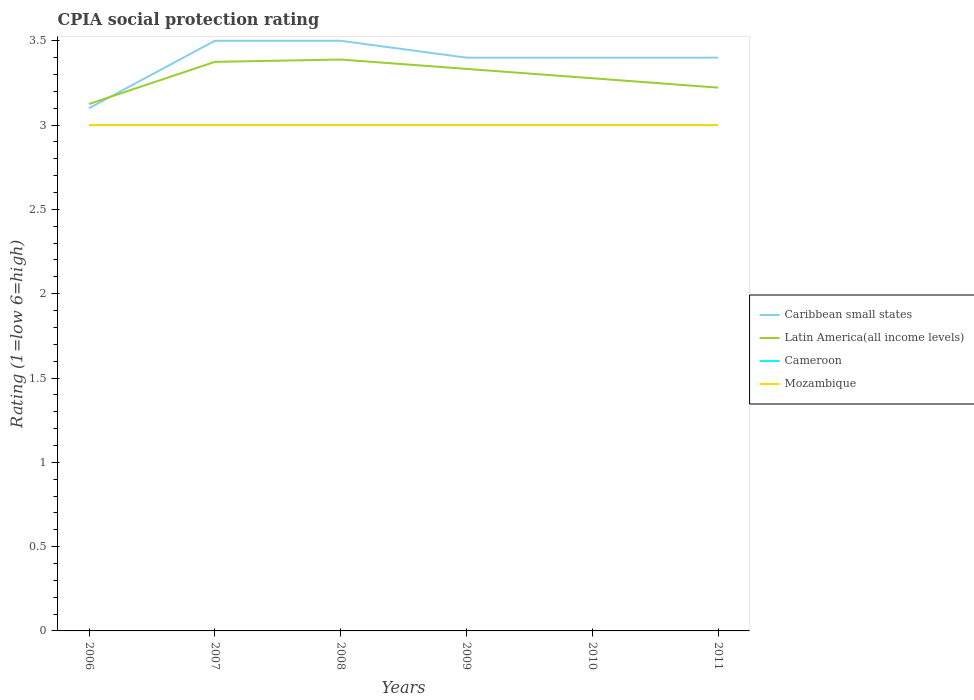How many different coloured lines are there?
Ensure brevity in your answer.  4. Does the line corresponding to Cameroon intersect with the line corresponding to Latin America(all income levels)?
Ensure brevity in your answer.  No. Across all years, what is the maximum CPIA rating in Latin America(all income levels)?
Provide a short and direct response. 3.12. In which year was the CPIA rating in Latin America(all income levels) maximum?
Give a very brief answer. 2006. What is the total CPIA rating in Latin America(all income levels) in the graph?
Your answer should be very brief. 0.06. What is the difference between the highest and the second highest CPIA rating in Latin America(all income levels)?
Provide a short and direct response. 0.26. Is the CPIA rating in Cameroon strictly greater than the CPIA rating in Caribbean small states over the years?
Keep it short and to the point. Yes. How many lines are there?
Provide a short and direct response. 4. What is the difference between two consecutive major ticks on the Y-axis?
Your answer should be compact. 0.5. Are the values on the major ticks of Y-axis written in scientific E-notation?
Make the answer very short. No. Does the graph contain grids?
Offer a terse response. No. How many legend labels are there?
Ensure brevity in your answer.  4. How are the legend labels stacked?
Make the answer very short. Vertical. What is the title of the graph?
Give a very brief answer. CPIA social protection rating. Does "American Samoa" appear as one of the legend labels in the graph?
Your answer should be compact. No. What is the label or title of the Y-axis?
Your response must be concise. Rating (1=low 6=high). What is the Rating (1=low 6=high) in Latin America(all income levels) in 2006?
Ensure brevity in your answer.  3.12. What is the Rating (1=low 6=high) of Latin America(all income levels) in 2007?
Give a very brief answer. 3.38. What is the Rating (1=low 6=high) of Latin America(all income levels) in 2008?
Keep it short and to the point. 3.39. What is the Rating (1=low 6=high) in Cameroon in 2008?
Your response must be concise. 3. What is the Rating (1=low 6=high) of Caribbean small states in 2009?
Provide a short and direct response. 3.4. What is the Rating (1=low 6=high) of Latin America(all income levels) in 2009?
Provide a succinct answer. 3.33. What is the Rating (1=low 6=high) of Cameroon in 2009?
Ensure brevity in your answer.  3. What is the Rating (1=low 6=high) of Caribbean small states in 2010?
Your answer should be compact. 3.4. What is the Rating (1=low 6=high) of Latin America(all income levels) in 2010?
Make the answer very short. 3.28. What is the Rating (1=low 6=high) in Cameroon in 2010?
Offer a very short reply. 3. What is the Rating (1=low 6=high) of Caribbean small states in 2011?
Provide a succinct answer. 3.4. What is the Rating (1=low 6=high) of Latin America(all income levels) in 2011?
Offer a very short reply. 3.22. What is the Rating (1=low 6=high) of Cameroon in 2011?
Ensure brevity in your answer.  3. What is the Rating (1=low 6=high) in Mozambique in 2011?
Offer a very short reply. 3. Across all years, what is the maximum Rating (1=low 6=high) of Caribbean small states?
Offer a very short reply. 3.5. Across all years, what is the maximum Rating (1=low 6=high) in Latin America(all income levels)?
Give a very brief answer. 3.39. Across all years, what is the maximum Rating (1=low 6=high) of Cameroon?
Provide a short and direct response. 3. Across all years, what is the maximum Rating (1=low 6=high) of Mozambique?
Your answer should be compact. 3. Across all years, what is the minimum Rating (1=low 6=high) in Caribbean small states?
Offer a very short reply. 3.1. Across all years, what is the minimum Rating (1=low 6=high) in Latin America(all income levels)?
Provide a succinct answer. 3.12. Across all years, what is the minimum Rating (1=low 6=high) of Cameroon?
Provide a succinct answer. 3. Across all years, what is the minimum Rating (1=low 6=high) in Mozambique?
Offer a very short reply. 3. What is the total Rating (1=low 6=high) of Caribbean small states in the graph?
Your answer should be very brief. 20.3. What is the total Rating (1=low 6=high) of Latin America(all income levels) in the graph?
Make the answer very short. 19.72. What is the difference between the Rating (1=low 6=high) of Caribbean small states in 2006 and that in 2007?
Offer a very short reply. -0.4. What is the difference between the Rating (1=low 6=high) in Latin America(all income levels) in 2006 and that in 2007?
Offer a terse response. -0.25. What is the difference between the Rating (1=low 6=high) in Cameroon in 2006 and that in 2007?
Offer a very short reply. 0. What is the difference between the Rating (1=low 6=high) of Caribbean small states in 2006 and that in 2008?
Offer a very short reply. -0.4. What is the difference between the Rating (1=low 6=high) in Latin America(all income levels) in 2006 and that in 2008?
Your answer should be compact. -0.26. What is the difference between the Rating (1=low 6=high) in Cameroon in 2006 and that in 2008?
Give a very brief answer. 0. What is the difference between the Rating (1=low 6=high) of Mozambique in 2006 and that in 2008?
Your answer should be very brief. 0. What is the difference between the Rating (1=low 6=high) of Latin America(all income levels) in 2006 and that in 2009?
Make the answer very short. -0.21. What is the difference between the Rating (1=low 6=high) in Cameroon in 2006 and that in 2009?
Your response must be concise. 0. What is the difference between the Rating (1=low 6=high) in Latin America(all income levels) in 2006 and that in 2010?
Ensure brevity in your answer.  -0.15. What is the difference between the Rating (1=low 6=high) in Mozambique in 2006 and that in 2010?
Ensure brevity in your answer.  0. What is the difference between the Rating (1=low 6=high) of Latin America(all income levels) in 2006 and that in 2011?
Make the answer very short. -0.1. What is the difference between the Rating (1=low 6=high) in Latin America(all income levels) in 2007 and that in 2008?
Your answer should be very brief. -0.01. What is the difference between the Rating (1=low 6=high) of Mozambique in 2007 and that in 2008?
Provide a succinct answer. 0. What is the difference between the Rating (1=low 6=high) in Latin America(all income levels) in 2007 and that in 2009?
Provide a short and direct response. 0.04. What is the difference between the Rating (1=low 6=high) of Mozambique in 2007 and that in 2009?
Your answer should be very brief. 0. What is the difference between the Rating (1=low 6=high) in Caribbean small states in 2007 and that in 2010?
Provide a succinct answer. 0.1. What is the difference between the Rating (1=low 6=high) of Latin America(all income levels) in 2007 and that in 2010?
Provide a succinct answer. 0.1. What is the difference between the Rating (1=low 6=high) of Mozambique in 2007 and that in 2010?
Make the answer very short. 0. What is the difference between the Rating (1=low 6=high) in Caribbean small states in 2007 and that in 2011?
Keep it short and to the point. 0.1. What is the difference between the Rating (1=low 6=high) in Latin America(all income levels) in 2007 and that in 2011?
Your response must be concise. 0.15. What is the difference between the Rating (1=low 6=high) in Caribbean small states in 2008 and that in 2009?
Provide a succinct answer. 0.1. What is the difference between the Rating (1=low 6=high) of Latin America(all income levels) in 2008 and that in 2009?
Provide a succinct answer. 0.06. What is the difference between the Rating (1=low 6=high) of Cameroon in 2008 and that in 2011?
Make the answer very short. 0. What is the difference between the Rating (1=low 6=high) of Caribbean small states in 2009 and that in 2010?
Provide a succinct answer. 0. What is the difference between the Rating (1=low 6=high) of Latin America(all income levels) in 2009 and that in 2010?
Offer a terse response. 0.06. What is the difference between the Rating (1=low 6=high) in Cameroon in 2009 and that in 2010?
Offer a very short reply. 0. What is the difference between the Rating (1=low 6=high) of Mozambique in 2009 and that in 2010?
Provide a short and direct response. 0. What is the difference between the Rating (1=low 6=high) in Caribbean small states in 2009 and that in 2011?
Your response must be concise. 0. What is the difference between the Rating (1=low 6=high) in Latin America(all income levels) in 2009 and that in 2011?
Offer a terse response. 0.11. What is the difference between the Rating (1=low 6=high) of Mozambique in 2009 and that in 2011?
Your response must be concise. 0. What is the difference between the Rating (1=low 6=high) in Caribbean small states in 2010 and that in 2011?
Keep it short and to the point. 0. What is the difference between the Rating (1=low 6=high) of Latin America(all income levels) in 2010 and that in 2011?
Keep it short and to the point. 0.06. What is the difference between the Rating (1=low 6=high) of Mozambique in 2010 and that in 2011?
Provide a short and direct response. 0. What is the difference between the Rating (1=low 6=high) in Caribbean small states in 2006 and the Rating (1=low 6=high) in Latin America(all income levels) in 2007?
Provide a succinct answer. -0.28. What is the difference between the Rating (1=low 6=high) of Caribbean small states in 2006 and the Rating (1=low 6=high) of Mozambique in 2007?
Provide a succinct answer. 0.1. What is the difference between the Rating (1=low 6=high) in Latin America(all income levels) in 2006 and the Rating (1=low 6=high) in Cameroon in 2007?
Your answer should be compact. 0.12. What is the difference between the Rating (1=low 6=high) in Latin America(all income levels) in 2006 and the Rating (1=low 6=high) in Mozambique in 2007?
Your answer should be very brief. 0.12. What is the difference between the Rating (1=low 6=high) of Cameroon in 2006 and the Rating (1=low 6=high) of Mozambique in 2007?
Provide a succinct answer. 0. What is the difference between the Rating (1=low 6=high) of Caribbean small states in 2006 and the Rating (1=low 6=high) of Latin America(all income levels) in 2008?
Make the answer very short. -0.29. What is the difference between the Rating (1=low 6=high) of Caribbean small states in 2006 and the Rating (1=low 6=high) of Cameroon in 2008?
Ensure brevity in your answer.  0.1. What is the difference between the Rating (1=low 6=high) in Caribbean small states in 2006 and the Rating (1=low 6=high) in Mozambique in 2008?
Offer a terse response. 0.1. What is the difference between the Rating (1=low 6=high) of Cameroon in 2006 and the Rating (1=low 6=high) of Mozambique in 2008?
Ensure brevity in your answer.  0. What is the difference between the Rating (1=low 6=high) in Caribbean small states in 2006 and the Rating (1=low 6=high) in Latin America(all income levels) in 2009?
Keep it short and to the point. -0.23. What is the difference between the Rating (1=low 6=high) of Caribbean small states in 2006 and the Rating (1=low 6=high) of Latin America(all income levels) in 2010?
Keep it short and to the point. -0.18. What is the difference between the Rating (1=low 6=high) of Caribbean small states in 2006 and the Rating (1=low 6=high) of Cameroon in 2010?
Your answer should be very brief. 0.1. What is the difference between the Rating (1=low 6=high) of Caribbean small states in 2006 and the Rating (1=low 6=high) of Mozambique in 2010?
Offer a very short reply. 0.1. What is the difference between the Rating (1=low 6=high) in Caribbean small states in 2006 and the Rating (1=low 6=high) in Latin America(all income levels) in 2011?
Offer a terse response. -0.12. What is the difference between the Rating (1=low 6=high) in Caribbean small states in 2006 and the Rating (1=low 6=high) in Cameroon in 2011?
Ensure brevity in your answer.  0.1. What is the difference between the Rating (1=low 6=high) of Caribbean small states in 2006 and the Rating (1=low 6=high) of Mozambique in 2011?
Provide a succinct answer. 0.1. What is the difference between the Rating (1=low 6=high) in Latin America(all income levels) in 2006 and the Rating (1=low 6=high) in Mozambique in 2011?
Give a very brief answer. 0.12. What is the difference between the Rating (1=low 6=high) in Cameroon in 2006 and the Rating (1=low 6=high) in Mozambique in 2011?
Your answer should be compact. 0. What is the difference between the Rating (1=low 6=high) in Caribbean small states in 2007 and the Rating (1=low 6=high) in Mozambique in 2008?
Give a very brief answer. 0.5. What is the difference between the Rating (1=low 6=high) in Latin America(all income levels) in 2007 and the Rating (1=low 6=high) in Mozambique in 2008?
Your answer should be compact. 0.38. What is the difference between the Rating (1=low 6=high) in Caribbean small states in 2007 and the Rating (1=low 6=high) in Latin America(all income levels) in 2009?
Your answer should be very brief. 0.17. What is the difference between the Rating (1=low 6=high) of Caribbean small states in 2007 and the Rating (1=low 6=high) of Mozambique in 2009?
Offer a terse response. 0.5. What is the difference between the Rating (1=low 6=high) in Latin America(all income levels) in 2007 and the Rating (1=low 6=high) in Mozambique in 2009?
Your answer should be compact. 0.38. What is the difference between the Rating (1=low 6=high) of Caribbean small states in 2007 and the Rating (1=low 6=high) of Latin America(all income levels) in 2010?
Your answer should be very brief. 0.22. What is the difference between the Rating (1=low 6=high) in Caribbean small states in 2007 and the Rating (1=low 6=high) in Cameroon in 2010?
Give a very brief answer. 0.5. What is the difference between the Rating (1=low 6=high) of Latin America(all income levels) in 2007 and the Rating (1=low 6=high) of Cameroon in 2010?
Give a very brief answer. 0.38. What is the difference between the Rating (1=low 6=high) in Latin America(all income levels) in 2007 and the Rating (1=low 6=high) in Mozambique in 2010?
Provide a short and direct response. 0.38. What is the difference between the Rating (1=low 6=high) of Caribbean small states in 2007 and the Rating (1=low 6=high) of Latin America(all income levels) in 2011?
Make the answer very short. 0.28. What is the difference between the Rating (1=low 6=high) of Caribbean small states in 2007 and the Rating (1=low 6=high) of Mozambique in 2011?
Your response must be concise. 0.5. What is the difference between the Rating (1=low 6=high) of Latin America(all income levels) in 2007 and the Rating (1=low 6=high) of Mozambique in 2011?
Give a very brief answer. 0.38. What is the difference between the Rating (1=low 6=high) in Cameroon in 2007 and the Rating (1=low 6=high) in Mozambique in 2011?
Make the answer very short. 0. What is the difference between the Rating (1=low 6=high) in Caribbean small states in 2008 and the Rating (1=low 6=high) in Latin America(all income levels) in 2009?
Give a very brief answer. 0.17. What is the difference between the Rating (1=low 6=high) of Caribbean small states in 2008 and the Rating (1=low 6=high) of Cameroon in 2009?
Keep it short and to the point. 0.5. What is the difference between the Rating (1=low 6=high) in Caribbean small states in 2008 and the Rating (1=low 6=high) in Mozambique in 2009?
Your answer should be compact. 0.5. What is the difference between the Rating (1=low 6=high) in Latin America(all income levels) in 2008 and the Rating (1=low 6=high) in Cameroon in 2009?
Offer a very short reply. 0.39. What is the difference between the Rating (1=low 6=high) of Latin America(all income levels) in 2008 and the Rating (1=low 6=high) of Mozambique in 2009?
Provide a short and direct response. 0.39. What is the difference between the Rating (1=low 6=high) in Cameroon in 2008 and the Rating (1=low 6=high) in Mozambique in 2009?
Your answer should be compact. 0. What is the difference between the Rating (1=low 6=high) in Caribbean small states in 2008 and the Rating (1=low 6=high) in Latin America(all income levels) in 2010?
Your answer should be compact. 0.22. What is the difference between the Rating (1=low 6=high) of Caribbean small states in 2008 and the Rating (1=low 6=high) of Cameroon in 2010?
Make the answer very short. 0.5. What is the difference between the Rating (1=low 6=high) in Caribbean small states in 2008 and the Rating (1=low 6=high) in Mozambique in 2010?
Keep it short and to the point. 0.5. What is the difference between the Rating (1=low 6=high) of Latin America(all income levels) in 2008 and the Rating (1=low 6=high) of Cameroon in 2010?
Your response must be concise. 0.39. What is the difference between the Rating (1=low 6=high) of Latin America(all income levels) in 2008 and the Rating (1=low 6=high) of Mozambique in 2010?
Make the answer very short. 0.39. What is the difference between the Rating (1=low 6=high) of Cameroon in 2008 and the Rating (1=low 6=high) of Mozambique in 2010?
Your answer should be very brief. 0. What is the difference between the Rating (1=low 6=high) of Caribbean small states in 2008 and the Rating (1=low 6=high) of Latin America(all income levels) in 2011?
Your answer should be compact. 0.28. What is the difference between the Rating (1=low 6=high) of Latin America(all income levels) in 2008 and the Rating (1=low 6=high) of Cameroon in 2011?
Provide a succinct answer. 0.39. What is the difference between the Rating (1=low 6=high) of Latin America(all income levels) in 2008 and the Rating (1=low 6=high) of Mozambique in 2011?
Provide a succinct answer. 0.39. What is the difference between the Rating (1=low 6=high) of Cameroon in 2008 and the Rating (1=low 6=high) of Mozambique in 2011?
Provide a short and direct response. 0. What is the difference between the Rating (1=low 6=high) in Caribbean small states in 2009 and the Rating (1=low 6=high) in Latin America(all income levels) in 2010?
Provide a succinct answer. 0.12. What is the difference between the Rating (1=low 6=high) of Caribbean small states in 2009 and the Rating (1=low 6=high) of Cameroon in 2010?
Ensure brevity in your answer.  0.4. What is the difference between the Rating (1=low 6=high) in Caribbean small states in 2009 and the Rating (1=low 6=high) in Mozambique in 2010?
Your answer should be very brief. 0.4. What is the difference between the Rating (1=low 6=high) of Latin America(all income levels) in 2009 and the Rating (1=low 6=high) of Cameroon in 2010?
Ensure brevity in your answer.  0.33. What is the difference between the Rating (1=low 6=high) in Caribbean small states in 2009 and the Rating (1=low 6=high) in Latin America(all income levels) in 2011?
Give a very brief answer. 0.18. What is the difference between the Rating (1=low 6=high) in Caribbean small states in 2009 and the Rating (1=low 6=high) in Cameroon in 2011?
Your answer should be compact. 0.4. What is the difference between the Rating (1=low 6=high) in Latin America(all income levels) in 2009 and the Rating (1=low 6=high) in Cameroon in 2011?
Your answer should be very brief. 0.33. What is the difference between the Rating (1=low 6=high) of Caribbean small states in 2010 and the Rating (1=low 6=high) of Latin America(all income levels) in 2011?
Keep it short and to the point. 0.18. What is the difference between the Rating (1=low 6=high) in Caribbean small states in 2010 and the Rating (1=low 6=high) in Cameroon in 2011?
Your answer should be very brief. 0.4. What is the difference between the Rating (1=low 6=high) of Caribbean small states in 2010 and the Rating (1=low 6=high) of Mozambique in 2011?
Offer a terse response. 0.4. What is the difference between the Rating (1=low 6=high) in Latin America(all income levels) in 2010 and the Rating (1=low 6=high) in Cameroon in 2011?
Offer a terse response. 0.28. What is the difference between the Rating (1=low 6=high) of Latin America(all income levels) in 2010 and the Rating (1=low 6=high) of Mozambique in 2011?
Your answer should be compact. 0.28. What is the difference between the Rating (1=low 6=high) of Cameroon in 2010 and the Rating (1=low 6=high) of Mozambique in 2011?
Ensure brevity in your answer.  0. What is the average Rating (1=low 6=high) of Caribbean small states per year?
Offer a terse response. 3.38. What is the average Rating (1=low 6=high) of Latin America(all income levels) per year?
Provide a short and direct response. 3.29. What is the average Rating (1=low 6=high) of Mozambique per year?
Offer a terse response. 3. In the year 2006, what is the difference between the Rating (1=low 6=high) of Caribbean small states and Rating (1=low 6=high) of Latin America(all income levels)?
Provide a short and direct response. -0.03. In the year 2006, what is the difference between the Rating (1=low 6=high) in Caribbean small states and Rating (1=low 6=high) in Cameroon?
Keep it short and to the point. 0.1. In the year 2006, what is the difference between the Rating (1=low 6=high) in Caribbean small states and Rating (1=low 6=high) in Mozambique?
Ensure brevity in your answer.  0.1. In the year 2006, what is the difference between the Rating (1=low 6=high) of Latin America(all income levels) and Rating (1=low 6=high) of Mozambique?
Give a very brief answer. 0.12. In the year 2007, what is the difference between the Rating (1=low 6=high) of Latin America(all income levels) and Rating (1=low 6=high) of Cameroon?
Provide a short and direct response. 0.38. In the year 2008, what is the difference between the Rating (1=low 6=high) in Caribbean small states and Rating (1=low 6=high) in Latin America(all income levels)?
Your answer should be compact. 0.11. In the year 2008, what is the difference between the Rating (1=low 6=high) in Caribbean small states and Rating (1=low 6=high) in Cameroon?
Ensure brevity in your answer.  0.5. In the year 2008, what is the difference between the Rating (1=low 6=high) of Latin America(all income levels) and Rating (1=low 6=high) of Cameroon?
Ensure brevity in your answer.  0.39. In the year 2008, what is the difference between the Rating (1=low 6=high) in Latin America(all income levels) and Rating (1=low 6=high) in Mozambique?
Ensure brevity in your answer.  0.39. In the year 2008, what is the difference between the Rating (1=low 6=high) in Cameroon and Rating (1=low 6=high) in Mozambique?
Provide a short and direct response. 0. In the year 2009, what is the difference between the Rating (1=low 6=high) in Caribbean small states and Rating (1=low 6=high) in Latin America(all income levels)?
Provide a succinct answer. 0.07. In the year 2009, what is the difference between the Rating (1=low 6=high) in Caribbean small states and Rating (1=low 6=high) in Cameroon?
Your answer should be very brief. 0.4. In the year 2009, what is the difference between the Rating (1=low 6=high) in Caribbean small states and Rating (1=low 6=high) in Mozambique?
Offer a very short reply. 0.4. In the year 2009, what is the difference between the Rating (1=low 6=high) of Latin America(all income levels) and Rating (1=low 6=high) of Cameroon?
Your answer should be compact. 0.33. In the year 2009, what is the difference between the Rating (1=low 6=high) in Cameroon and Rating (1=low 6=high) in Mozambique?
Provide a short and direct response. 0. In the year 2010, what is the difference between the Rating (1=low 6=high) of Caribbean small states and Rating (1=low 6=high) of Latin America(all income levels)?
Give a very brief answer. 0.12. In the year 2010, what is the difference between the Rating (1=low 6=high) in Caribbean small states and Rating (1=low 6=high) in Cameroon?
Ensure brevity in your answer.  0.4. In the year 2010, what is the difference between the Rating (1=low 6=high) of Caribbean small states and Rating (1=low 6=high) of Mozambique?
Your answer should be compact. 0.4. In the year 2010, what is the difference between the Rating (1=low 6=high) in Latin America(all income levels) and Rating (1=low 6=high) in Cameroon?
Your response must be concise. 0.28. In the year 2010, what is the difference between the Rating (1=low 6=high) of Latin America(all income levels) and Rating (1=low 6=high) of Mozambique?
Offer a terse response. 0.28. In the year 2010, what is the difference between the Rating (1=low 6=high) in Cameroon and Rating (1=low 6=high) in Mozambique?
Provide a short and direct response. 0. In the year 2011, what is the difference between the Rating (1=low 6=high) of Caribbean small states and Rating (1=low 6=high) of Latin America(all income levels)?
Your answer should be compact. 0.18. In the year 2011, what is the difference between the Rating (1=low 6=high) in Caribbean small states and Rating (1=low 6=high) in Cameroon?
Your answer should be very brief. 0.4. In the year 2011, what is the difference between the Rating (1=low 6=high) of Latin America(all income levels) and Rating (1=low 6=high) of Cameroon?
Your answer should be very brief. 0.22. In the year 2011, what is the difference between the Rating (1=low 6=high) in Latin America(all income levels) and Rating (1=low 6=high) in Mozambique?
Your response must be concise. 0.22. In the year 2011, what is the difference between the Rating (1=low 6=high) in Cameroon and Rating (1=low 6=high) in Mozambique?
Ensure brevity in your answer.  0. What is the ratio of the Rating (1=low 6=high) in Caribbean small states in 2006 to that in 2007?
Make the answer very short. 0.89. What is the ratio of the Rating (1=low 6=high) of Latin America(all income levels) in 2006 to that in 2007?
Give a very brief answer. 0.93. What is the ratio of the Rating (1=low 6=high) in Cameroon in 2006 to that in 2007?
Make the answer very short. 1. What is the ratio of the Rating (1=low 6=high) in Caribbean small states in 2006 to that in 2008?
Ensure brevity in your answer.  0.89. What is the ratio of the Rating (1=low 6=high) of Latin America(all income levels) in 2006 to that in 2008?
Your answer should be very brief. 0.92. What is the ratio of the Rating (1=low 6=high) of Cameroon in 2006 to that in 2008?
Give a very brief answer. 1. What is the ratio of the Rating (1=low 6=high) in Mozambique in 2006 to that in 2008?
Your answer should be compact. 1. What is the ratio of the Rating (1=low 6=high) in Caribbean small states in 2006 to that in 2009?
Offer a very short reply. 0.91. What is the ratio of the Rating (1=low 6=high) in Latin America(all income levels) in 2006 to that in 2009?
Offer a very short reply. 0.94. What is the ratio of the Rating (1=low 6=high) of Cameroon in 2006 to that in 2009?
Your response must be concise. 1. What is the ratio of the Rating (1=low 6=high) in Mozambique in 2006 to that in 2009?
Your response must be concise. 1. What is the ratio of the Rating (1=low 6=high) of Caribbean small states in 2006 to that in 2010?
Keep it short and to the point. 0.91. What is the ratio of the Rating (1=low 6=high) in Latin America(all income levels) in 2006 to that in 2010?
Offer a terse response. 0.95. What is the ratio of the Rating (1=low 6=high) in Mozambique in 2006 to that in 2010?
Make the answer very short. 1. What is the ratio of the Rating (1=low 6=high) of Caribbean small states in 2006 to that in 2011?
Your response must be concise. 0.91. What is the ratio of the Rating (1=low 6=high) in Latin America(all income levels) in 2006 to that in 2011?
Make the answer very short. 0.97. What is the ratio of the Rating (1=low 6=high) of Cameroon in 2006 to that in 2011?
Offer a very short reply. 1. What is the ratio of the Rating (1=low 6=high) in Cameroon in 2007 to that in 2008?
Offer a very short reply. 1. What is the ratio of the Rating (1=low 6=high) in Caribbean small states in 2007 to that in 2009?
Ensure brevity in your answer.  1.03. What is the ratio of the Rating (1=low 6=high) in Latin America(all income levels) in 2007 to that in 2009?
Your response must be concise. 1.01. What is the ratio of the Rating (1=low 6=high) in Cameroon in 2007 to that in 2009?
Offer a very short reply. 1. What is the ratio of the Rating (1=low 6=high) of Mozambique in 2007 to that in 2009?
Give a very brief answer. 1. What is the ratio of the Rating (1=low 6=high) of Caribbean small states in 2007 to that in 2010?
Your answer should be compact. 1.03. What is the ratio of the Rating (1=low 6=high) in Latin America(all income levels) in 2007 to that in 2010?
Ensure brevity in your answer.  1.03. What is the ratio of the Rating (1=low 6=high) in Cameroon in 2007 to that in 2010?
Your response must be concise. 1. What is the ratio of the Rating (1=low 6=high) in Caribbean small states in 2007 to that in 2011?
Your response must be concise. 1.03. What is the ratio of the Rating (1=low 6=high) in Latin America(all income levels) in 2007 to that in 2011?
Give a very brief answer. 1.05. What is the ratio of the Rating (1=low 6=high) in Cameroon in 2007 to that in 2011?
Provide a succinct answer. 1. What is the ratio of the Rating (1=low 6=high) in Caribbean small states in 2008 to that in 2009?
Make the answer very short. 1.03. What is the ratio of the Rating (1=low 6=high) in Latin America(all income levels) in 2008 to that in 2009?
Provide a short and direct response. 1.02. What is the ratio of the Rating (1=low 6=high) in Cameroon in 2008 to that in 2009?
Keep it short and to the point. 1. What is the ratio of the Rating (1=low 6=high) in Mozambique in 2008 to that in 2009?
Offer a very short reply. 1. What is the ratio of the Rating (1=low 6=high) in Caribbean small states in 2008 to that in 2010?
Give a very brief answer. 1.03. What is the ratio of the Rating (1=low 6=high) of Latin America(all income levels) in 2008 to that in 2010?
Your answer should be compact. 1.03. What is the ratio of the Rating (1=low 6=high) of Cameroon in 2008 to that in 2010?
Give a very brief answer. 1. What is the ratio of the Rating (1=low 6=high) in Mozambique in 2008 to that in 2010?
Give a very brief answer. 1. What is the ratio of the Rating (1=low 6=high) in Caribbean small states in 2008 to that in 2011?
Ensure brevity in your answer.  1.03. What is the ratio of the Rating (1=low 6=high) of Latin America(all income levels) in 2008 to that in 2011?
Offer a very short reply. 1.05. What is the ratio of the Rating (1=low 6=high) in Cameroon in 2008 to that in 2011?
Offer a terse response. 1. What is the ratio of the Rating (1=low 6=high) in Mozambique in 2008 to that in 2011?
Make the answer very short. 1. What is the ratio of the Rating (1=low 6=high) of Latin America(all income levels) in 2009 to that in 2010?
Make the answer very short. 1.02. What is the ratio of the Rating (1=low 6=high) of Cameroon in 2009 to that in 2010?
Keep it short and to the point. 1. What is the ratio of the Rating (1=low 6=high) of Latin America(all income levels) in 2009 to that in 2011?
Offer a very short reply. 1.03. What is the ratio of the Rating (1=low 6=high) in Caribbean small states in 2010 to that in 2011?
Your answer should be compact. 1. What is the ratio of the Rating (1=low 6=high) of Latin America(all income levels) in 2010 to that in 2011?
Ensure brevity in your answer.  1.02. What is the ratio of the Rating (1=low 6=high) of Cameroon in 2010 to that in 2011?
Offer a terse response. 1. What is the ratio of the Rating (1=low 6=high) of Mozambique in 2010 to that in 2011?
Your answer should be very brief. 1. What is the difference between the highest and the second highest Rating (1=low 6=high) of Caribbean small states?
Keep it short and to the point. 0. What is the difference between the highest and the second highest Rating (1=low 6=high) of Latin America(all income levels)?
Your answer should be compact. 0.01. What is the difference between the highest and the lowest Rating (1=low 6=high) in Caribbean small states?
Provide a short and direct response. 0.4. What is the difference between the highest and the lowest Rating (1=low 6=high) of Latin America(all income levels)?
Provide a short and direct response. 0.26. What is the difference between the highest and the lowest Rating (1=low 6=high) of Cameroon?
Your answer should be very brief. 0. 